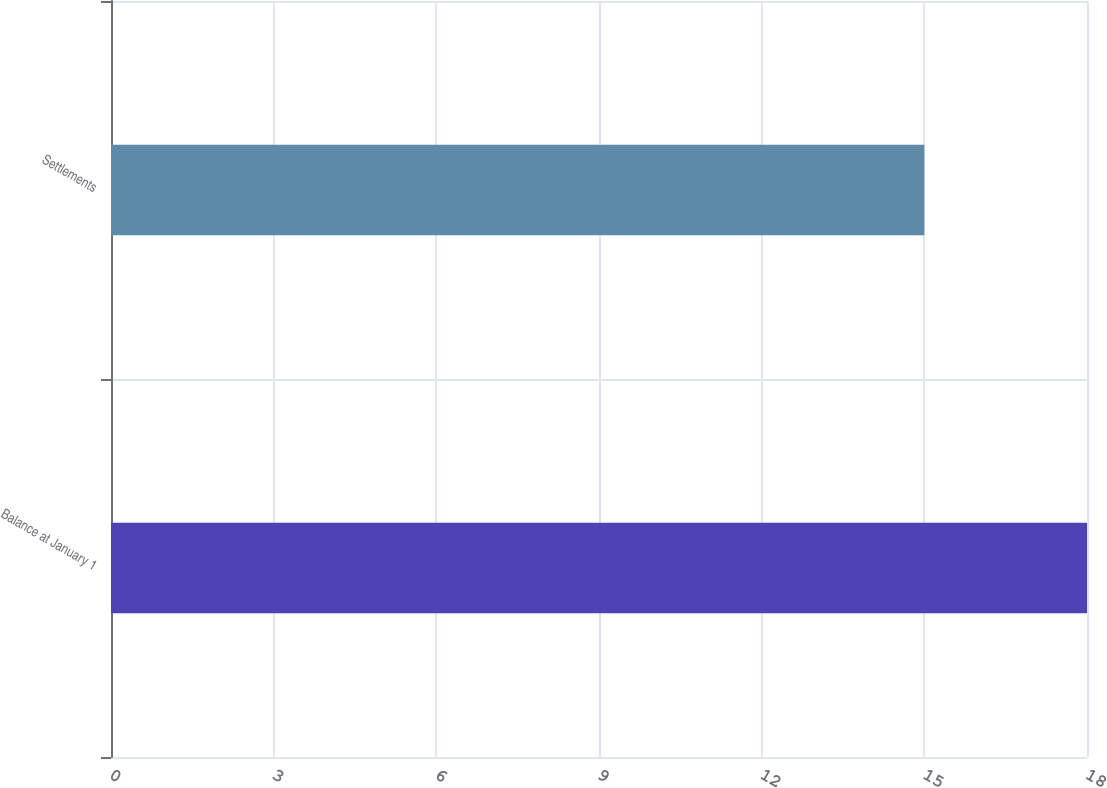Convert chart to OTSL. <chart><loc_0><loc_0><loc_500><loc_500><bar_chart><fcel>Balance at January 1<fcel>Settlements<nl><fcel>18<fcel>15<nl></chart> 